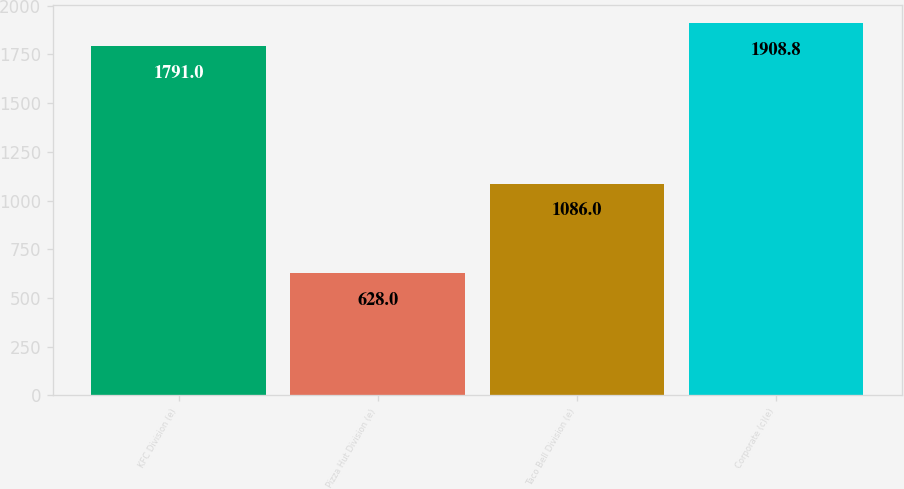Convert chart to OTSL. <chart><loc_0><loc_0><loc_500><loc_500><bar_chart><fcel>KFC Division (e)<fcel>Pizza Hut Division (e)<fcel>Taco Bell Division (e)<fcel>Corporate (c)(e)<nl><fcel>1791<fcel>628<fcel>1086<fcel>1908.8<nl></chart> 